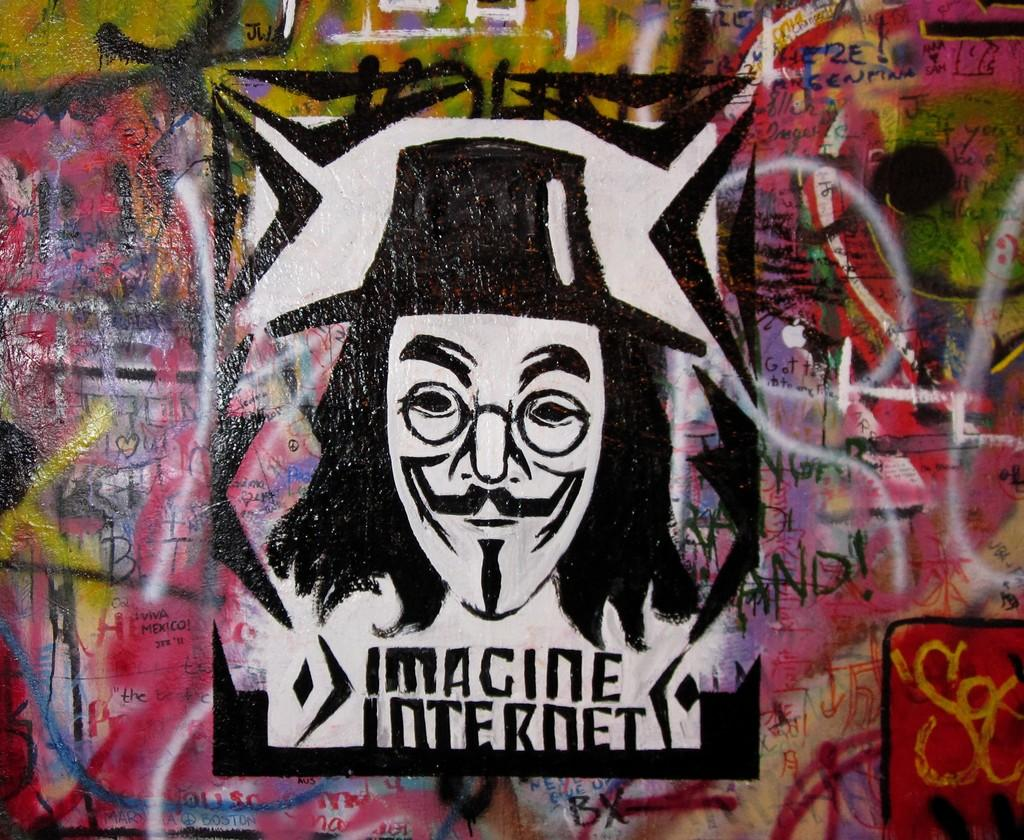What is the main subject of the wall painting in the image? The wall painting depicts a person. What type of art is featured in the image? There is a wall painting in the image. What type of wool is used to create the person's clothing in the wall painting? There is no information about the materials used in the wall painting, and the image does not show any clothing details. 